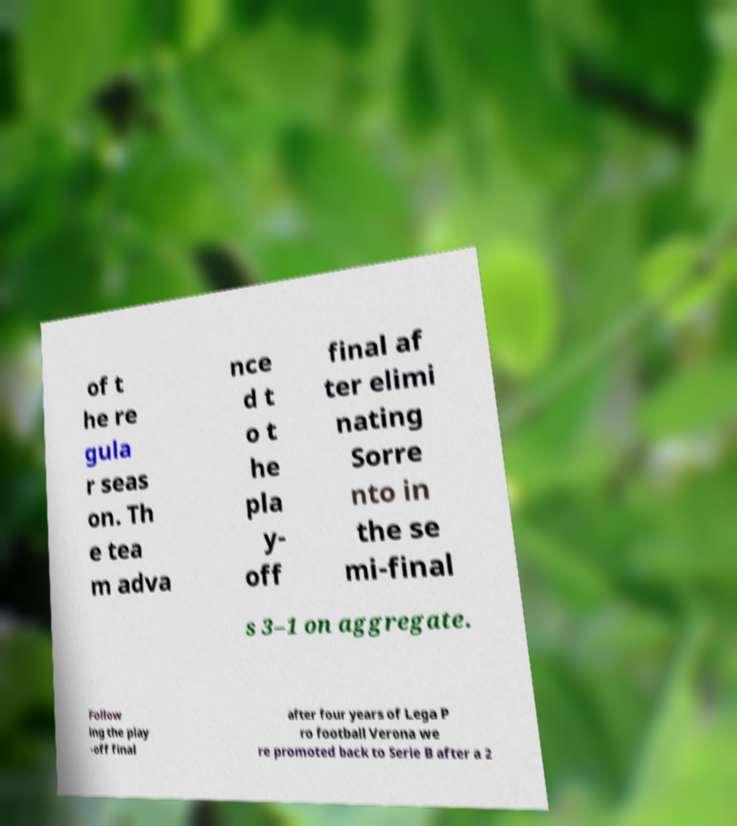Could you extract and type out the text from this image? of t he re gula r seas on. Th e tea m adva nce d t o t he pla y- off final af ter elimi nating Sorre nto in the se mi-final s 3–1 on aggregate. Follow ing the play -off final after four years of Lega P ro football Verona we re promoted back to Serie B after a 2 